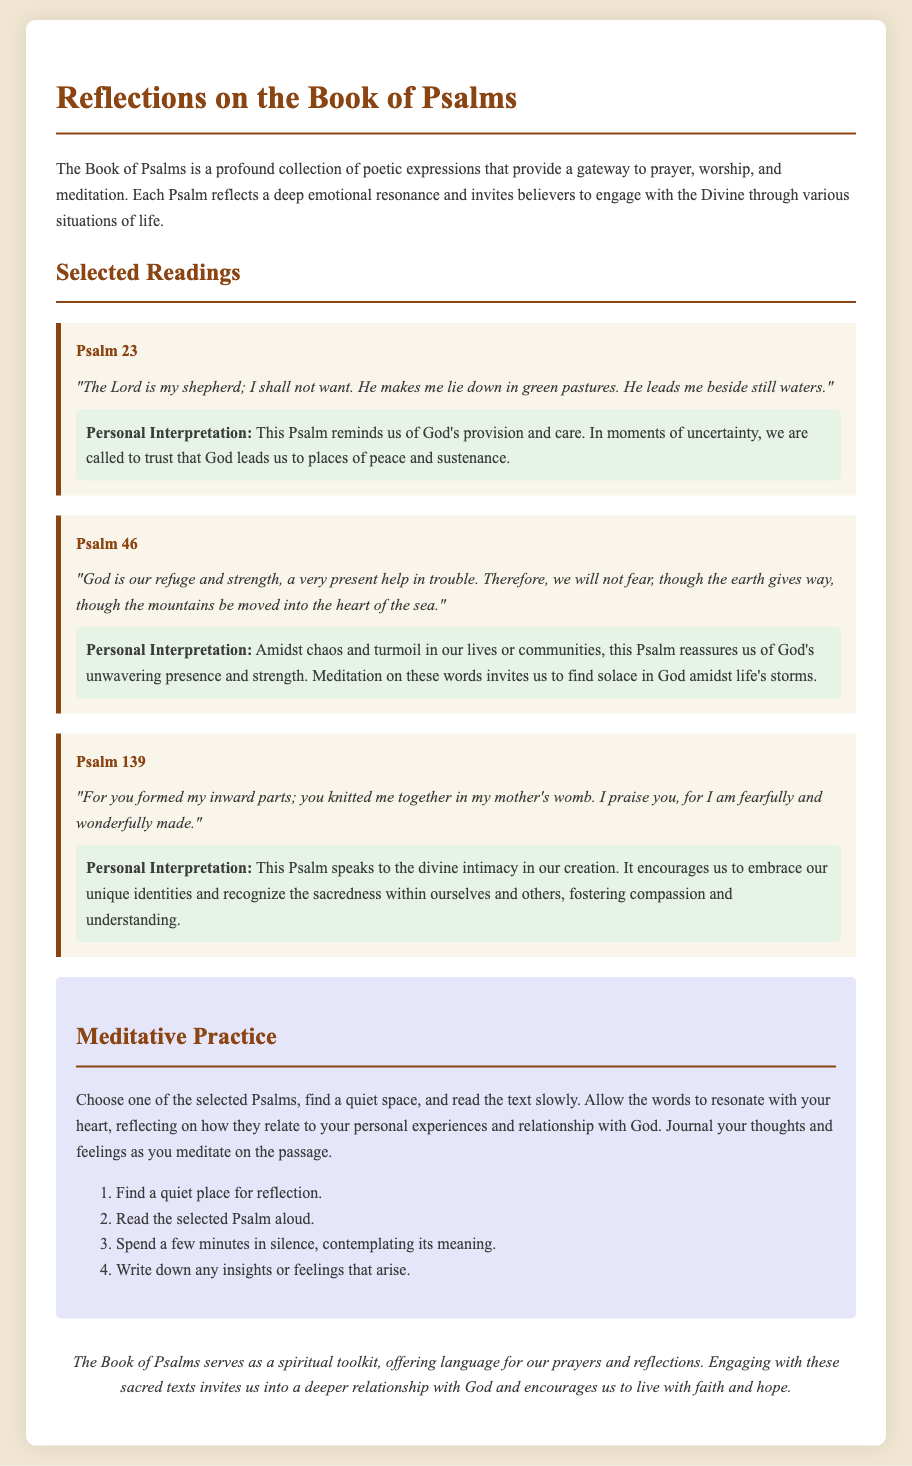What is the title of the document? The title of the document is displayed prominently at the top of the page.
Answer: Reflections on the Book of Psalms How many selected Psalms are included in the document? Three specific Psalms are presented with interpretations.
Answer: Three What is the first line of Psalm 23? The first line of Psalm 23 is presented in italic form.
Answer: The Lord is my shepherd; I shall not want What does the personal interpretation of Psalm 46 focus on? The interpretation discusses God's presence and strength during chaos.
Answer: God's unwavering presence and strength What practice is suggested in the meditative section? The document outlines steps for meditation on a selected Psalm.
Answer: Journal your thoughts and feelings Which Psalm emphasizes being "fearfully and wonderfully made"? This specific Psalm discusses the unique identity and creation of individuals.
Answer: Psalm 139 What color is used for the interpretation section? The interpretation section features a distinct background color.
Answer: Light green What should you do after reading the selected Psalm aloud? The document provides a sequence of actions to follow during meditation.
Answer: Spend a few minutes in silence What is the focus of the conclusion in the document? The conclusion summarizes the purpose of the Book of Psalms regarding spiritual practice.
Answer: Deeper relationship with God 